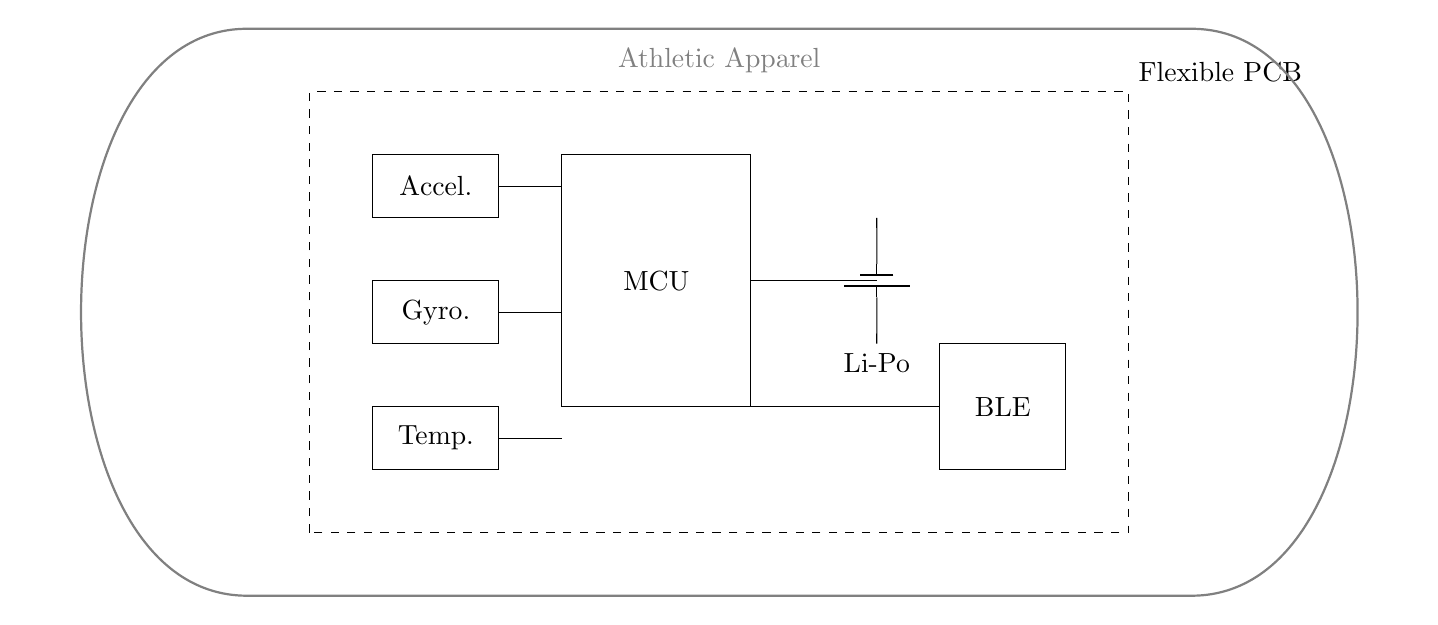What type of battery is shown in the circuit? The circuit diagram indicates a Li-Po battery, which is a common type of rechargeable battery used in mobile devices. It is labeled clearly next to the battery symbol.
Answer: Li-Po How many sensors are integrated into this circuit? The circuit contains three sensors: an accelerometer, a gyroscope, and a temperature sensor. Each sensor is represented by a rectangle labeled accordingly, showing their presence in the design.
Answer: Three What does BLE stand for in this circuit? BLE stands for Bluetooth Low Energy, which indicates that the circuit includes a wireless communication module. This is essential for connectivity while minimizing power consumption, as labeled in the circuit.
Answer: Bluetooth Low Energy Which component connects to the microcontroller on the left side? The accelerometer, gyroscope, and temperature sensor connect to the microcontroller; the lines connect these components directly to the MCU, showing how they communicate within the circuit.
Answer: Accelerometer, Gyroscope, Temperature sensor What is the main purpose of this circuit? The main purpose of this circuit is to integrate sensors into athletic apparel, allowing for the monitoring of various metrics during athletic activities. It achieves this through the combined functionality of the sensors and wireless communication with the microcontroller.
Answer: Integrating sensors into athletic apparel Where is the flexible PCB indicated in the diagram? The flexible PCB is represented by a dashed rectangle that outlines the areas where the components are placed. It is specifically labeled “Flexible PCB,” providing clear information about its role in the circuit.
Answer: Dashed rectangle labeled "Flexible PCB" 